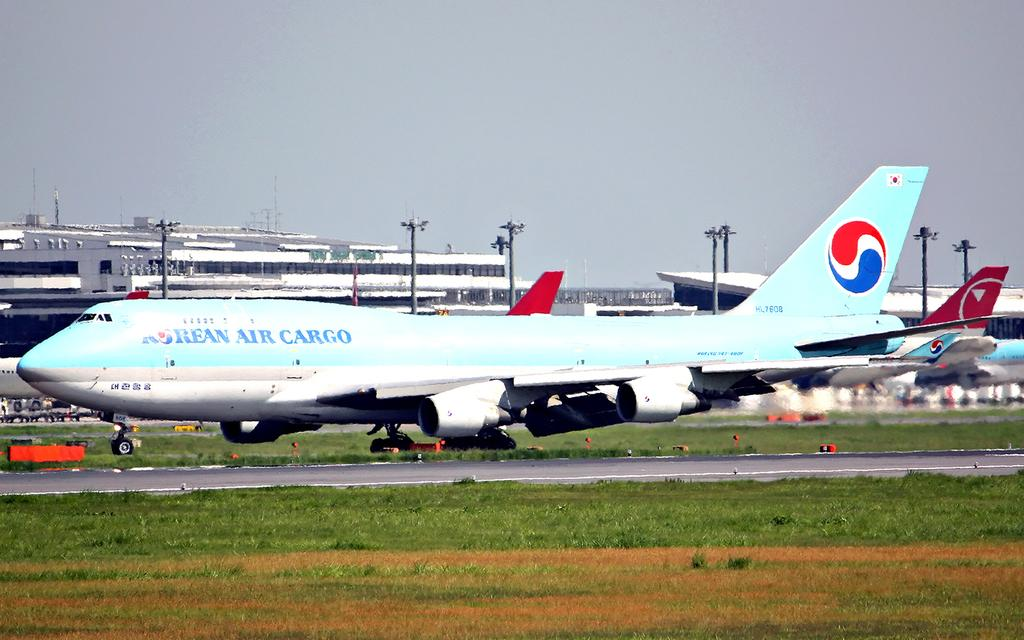<image>
Relay a brief, clear account of the picture shown. A Koren Air Cargo is parked outside of an airport. 